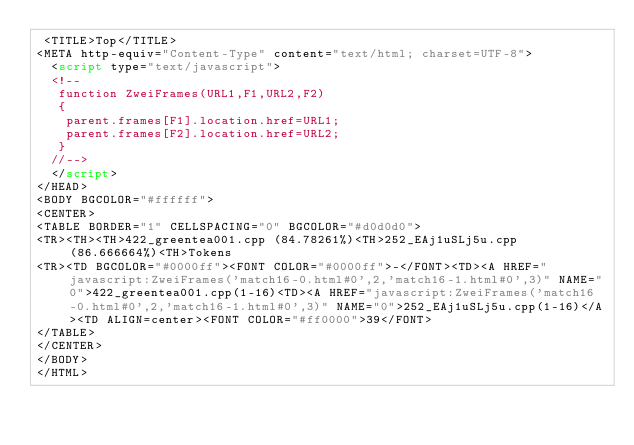<code> <loc_0><loc_0><loc_500><loc_500><_HTML_> <TITLE>Top</TITLE>
<META http-equiv="Content-Type" content="text/html; charset=UTF-8">
  <script type="text/javascript">
  <!--
   function ZweiFrames(URL1,F1,URL2,F2)
   {
    parent.frames[F1].location.href=URL1;
    parent.frames[F2].location.href=URL2;
   }
  //-->
  </script>
</HEAD>
<BODY BGCOLOR="#ffffff">
<CENTER>
<TABLE BORDER="1" CELLSPACING="0" BGCOLOR="#d0d0d0">
<TR><TH><TH>422_greentea001.cpp (84.78261%)<TH>252_EAj1uSLj5u.cpp (86.666664%)<TH>Tokens
<TR><TD BGCOLOR="#0000ff"><FONT COLOR="#0000ff">-</FONT><TD><A HREF="javascript:ZweiFrames('match16-0.html#0',2,'match16-1.html#0',3)" NAME="0">422_greentea001.cpp(1-16)<TD><A HREF="javascript:ZweiFrames('match16-0.html#0',2,'match16-1.html#0',3)" NAME="0">252_EAj1uSLj5u.cpp(1-16)</A><TD ALIGN=center><FONT COLOR="#ff0000">39</FONT>
</TABLE>
</CENTER>
</BODY>
</HTML>

</code> 